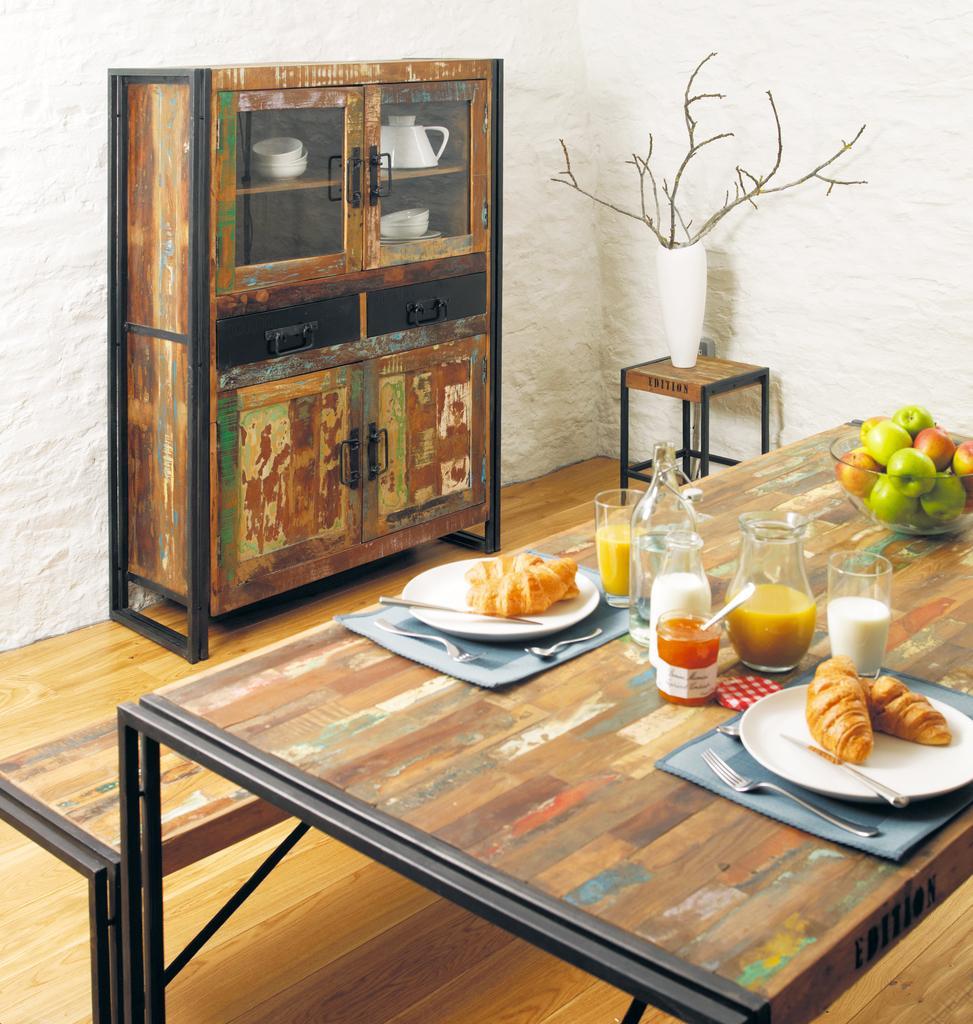Could you give a brief overview of what you see in this image? This is a table. On the table there are plates, glasses, bowl, bottle, forks, spoons, fruits, and food. This is floor. There is a cupboard, table, vase, bowls, and a jar. In the background we can see wall. 